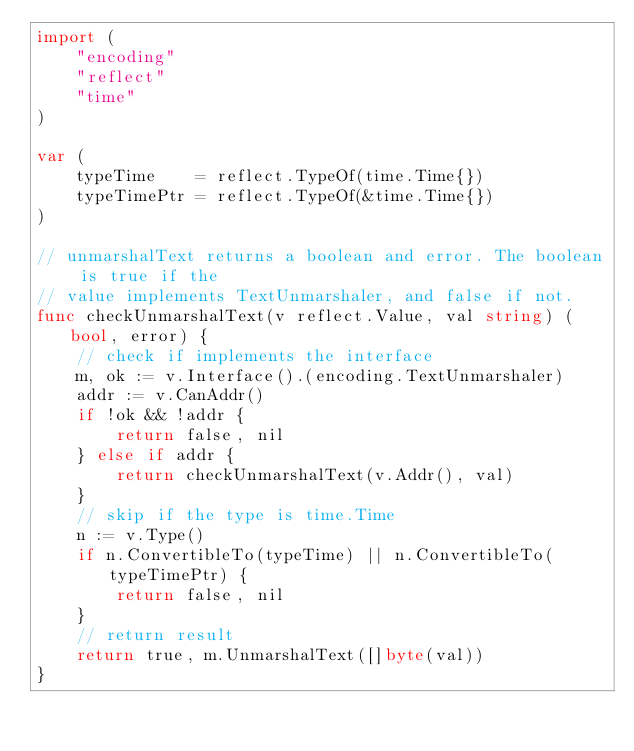Convert code to text. <code><loc_0><loc_0><loc_500><loc_500><_Go_>import (
	"encoding"
	"reflect"
	"time"
)

var (
	typeTime    = reflect.TypeOf(time.Time{})
	typeTimePtr = reflect.TypeOf(&time.Time{})
)

// unmarshalText returns a boolean and error. The boolean is true if the
// value implements TextUnmarshaler, and false if not.
func checkUnmarshalText(v reflect.Value, val string) (bool, error) {
	// check if implements the interface
	m, ok := v.Interface().(encoding.TextUnmarshaler)
	addr := v.CanAddr()
	if !ok && !addr {
		return false, nil
	} else if addr {
		return checkUnmarshalText(v.Addr(), val)
	}
	// skip if the type is time.Time
	n := v.Type()
	if n.ConvertibleTo(typeTime) || n.ConvertibleTo(typeTimePtr) {
		return false, nil
	}
	// return result
	return true, m.UnmarshalText([]byte(val))
}
</code> 